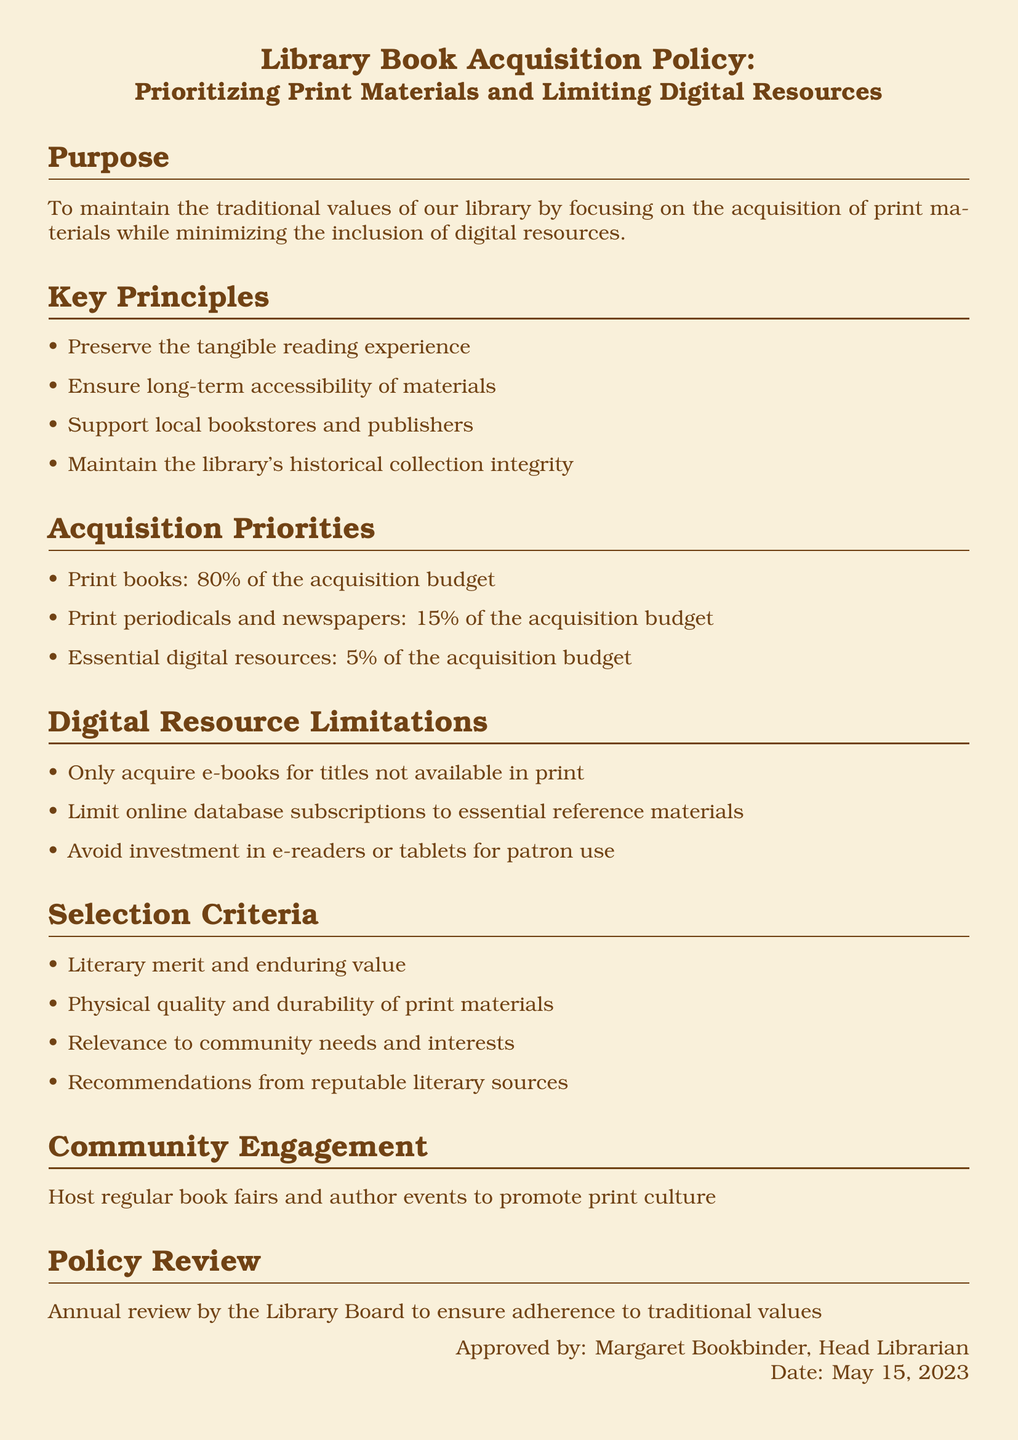What is the purpose of the policy? The purpose is outlined in the document, stating it aims to maintain traditional values by focusing on print materials and minimizing digital resources.
Answer: To maintain the traditional values of our library by focusing on the acquisition of print materials while minimizing the inclusion of digital resources How much of the acquisition budget is allocated to print books? The allocation for print books is specified in the acquisition priorities section.
Answer: 80 percent What percentage of the budget is designated for essential digital resources? The budget allocation for essential digital resources is listed in the acquisition priorities section.
Answer: 5 percent What criteria is used for selecting print materials? Selection criteria are detailed in a specific section, summarizing the factors considered.
Answer: Literary merit and enduring value What limitations are placed on digital resources? The document outlines specific limitations regarding the acquisition of digital resources in a dedicated section.
Answer: Only acquire e-books for titles not available in print Who approved the policy? The document mentions the individual who approved the policy at the end of the document.
Answer: Margaret Bookbinder When was the policy approved? The approval date for the policy is specified in the document.
Answer: May 15, 2023 What type of community engagement is included in the policy? The community engagement method is described in a dedicated section.
Answer: Host regular book fairs and author events to promote print culture 